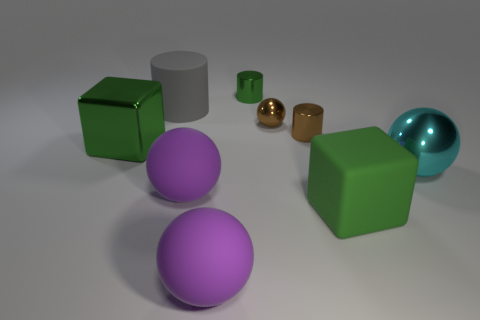Subtract all small cylinders. How many cylinders are left? 1 Subtract all brown cylinders. How many cylinders are left? 2 Subtract 1 blocks. How many blocks are left? 1 Subtract all cubes. How many objects are left? 7 Subtract 0 blue cylinders. How many objects are left? 9 Subtract all brown spheres. Subtract all green blocks. How many spheres are left? 3 Subtract all blue blocks. How many gray cylinders are left? 1 Subtract all green matte cylinders. Subtract all gray matte cylinders. How many objects are left? 8 Add 3 small things. How many small things are left? 6 Add 3 green rubber objects. How many green rubber objects exist? 4 